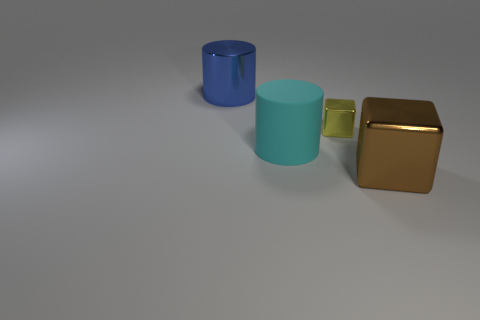What is the blue cylinder made of?
Your response must be concise. Metal. Is the cylinder that is behind the small yellow thing made of the same material as the cyan thing?
Offer a very short reply. No. Is the number of big cyan things that are to the right of the cyan rubber object less than the number of rubber things?
Give a very brief answer. Yes. What color is the metallic thing that is the same size as the brown metallic cube?
Provide a short and direct response. Blue. What number of small blue matte objects are the same shape as the blue metallic thing?
Your response must be concise. 0. There is a cylinder that is on the right side of the big blue shiny object; what color is it?
Offer a terse response. Cyan. How many shiny things are either blocks or cylinders?
Offer a terse response. 3. What number of blocks have the same size as the brown object?
Provide a succinct answer. 0. The thing that is in front of the tiny cube and behind the brown object is what color?
Your answer should be very brief. Cyan. What number of objects are big blue cylinders or brown blocks?
Your answer should be compact. 2. 